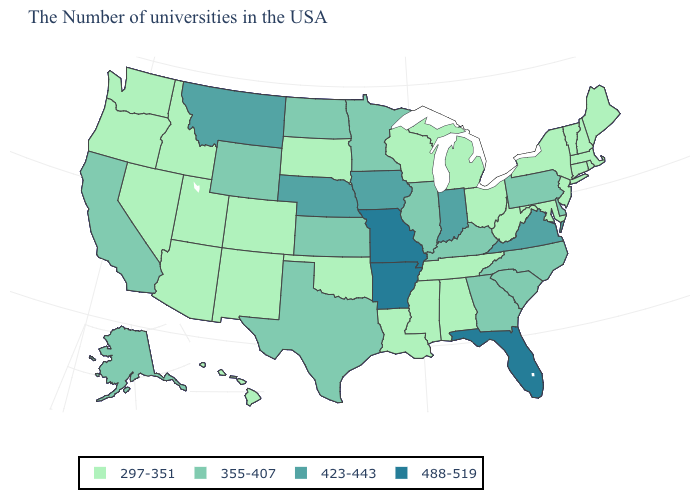Which states have the highest value in the USA?
Short answer required. Florida, Missouri, Arkansas. Which states have the highest value in the USA?
Write a very short answer. Florida, Missouri, Arkansas. Name the states that have a value in the range 488-519?
Short answer required. Florida, Missouri, Arkansas. What is the value of Maine?
Write a very short answer. 297-351. What is the lowest value in states that border Nevada?
Keep it brief. 297-351. Name the states that have a value in the range 488-519?
Give a very brief answer. Florida, Missouri, Arkansas. Does South Carolina have a lower value than Louisiana?
Write a very short answer. No. Name the states that have a value in the range 423-443?
Concise answer only. Virginia, Indiana, Iowa, Nebraska, Montana. Does Montana have the highest value in the West?
Answer briefly. Yes. Does Ohio have the same value as Florida?
Write a very short answer. No. Does Arkansas have the highest value in the USA?
Short answer required. Yes. Does Arkansas have the highest value in the USA?
Quick response, please. Yes. Does Mississippi have the lowest value in the USA?
Quick response, please. Yes. What is the value of Virginia?
Be succinct. 423-443. Does the map have missing data?
Give a very brief answer. No. 